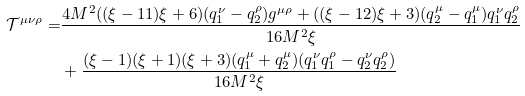<formula> <loc_0><loc_0><loc_500><loc_500>\mathcal { T } ^ { \mu \nu \rho } = & \frac { 4 M ^ { 2 } ( ( \xi - 1 1 ) \xi + 6 ) ( q _ { 1 } ^ { \nu } - q _ { 2 } ^ { \rho } ) g ^ { \mu \rho } + ( ( \xi - 1 2 ) \xi + 3 ) ( q _ { 2 } ^ { \mu } - q _ { 1 } ^ { \mu } ) q _ { 1 } ^ { \nu } q _ { 2 } ^ { \rho } } { 1 6 M ^ { 2 } \xi } \\ & + \frac { ( \xi - 1 ) ( \xi + 1 ) ( \xi + 3 ) ( q _ { 1 } ^ { \mu } + q _ { 2 } ^ { \mu } ) ( q _ { 1 } ^ { \nu } q _ { 1 } ^ { \rho } - q _ { 2 } ^ { \nu } q _ { 2 } ^ { \rho } ) } { 1 6 M ^ { 2 } \xi }</formula> 